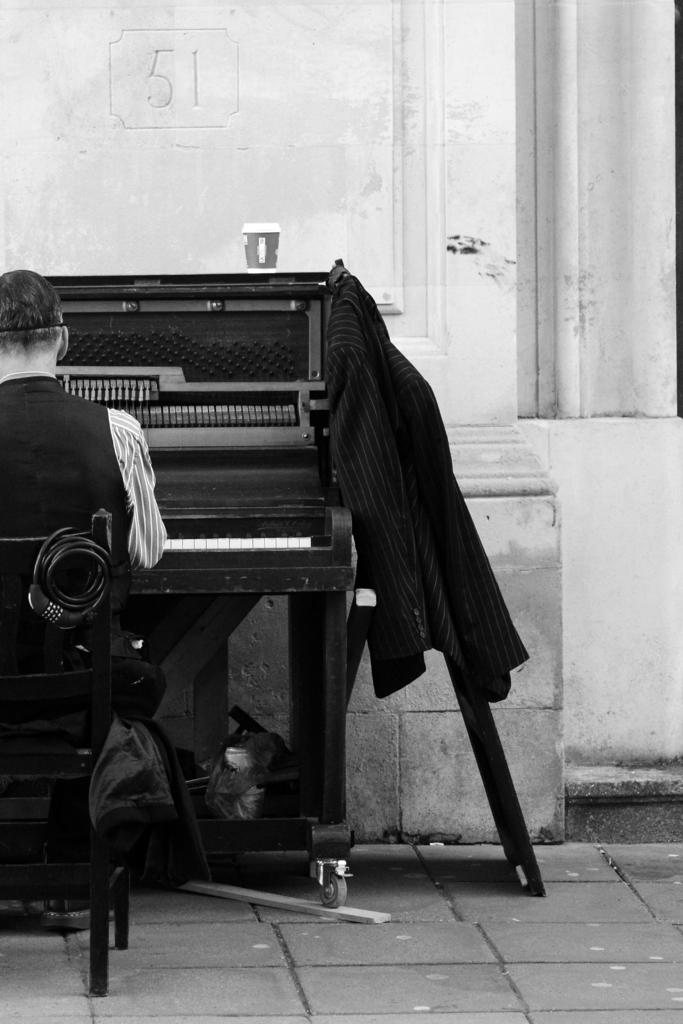What is the person in the image doing? There is a human sitting on a chair in the image. What object related to music can be seen in the image? There is a musical player in the image. What type of clothing is present in the image? There is a suit in the image. What circular object can be seen in the image? There is a wheel in the image. What is on the table in the image? There is a cup on a table in the image. What is visible in the background of the image? There is a wall in the background of the image. Where is the faucet located in the image? There is no faucet present in the image. What type of glass is being used by the person in the image? There is no glass visible in the image. 